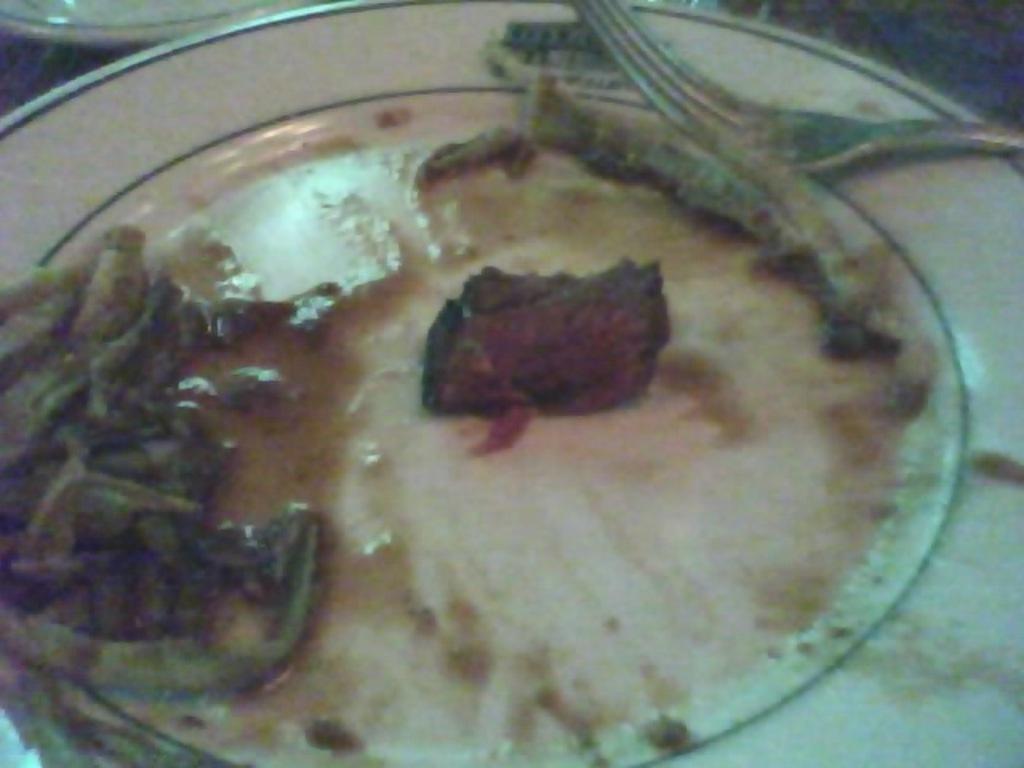Please provide a concise description of this image. In this image I can see food item on the white color plate. Food is in red and brown color. I can see a fork. 